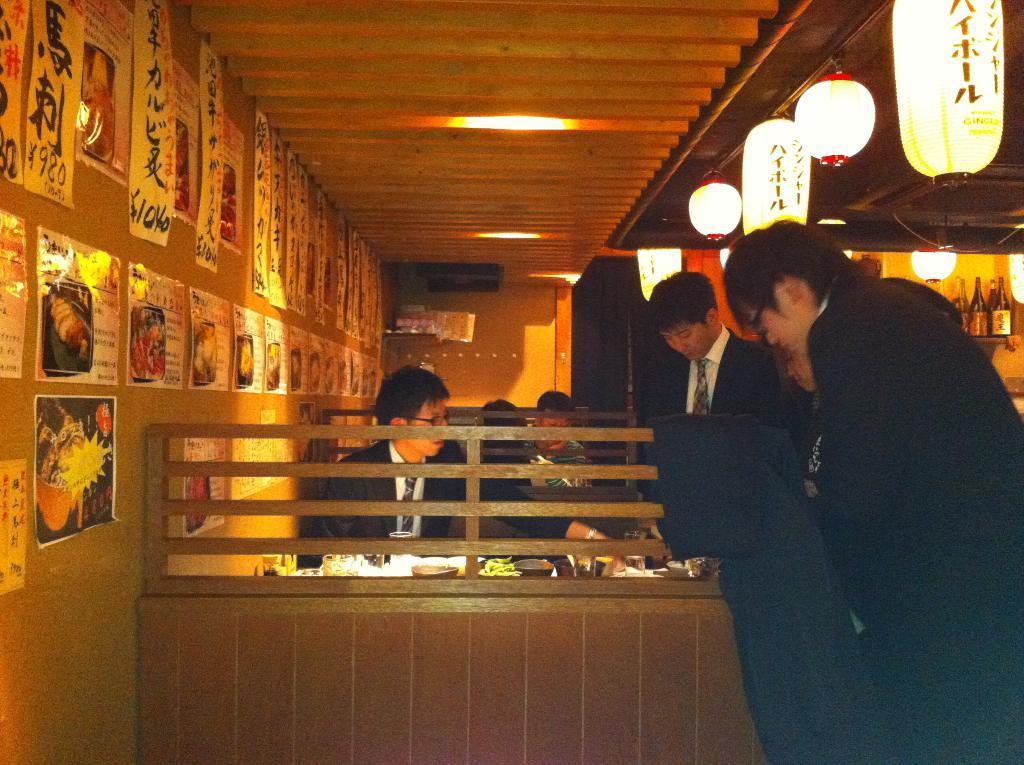In one or two sentences, can you explain what this image depicts? On the right side, we see the people are standing. In front of the picture, we see a man is sitting on the chair. In front of him, we see a table on which the glasses, bowls and some other objects are placed. Behind him, we see two people are sitting. On the right side, we see a rack in which the glass bottles are placed. In the background, we see a wall. On the left side, we see a brown wall on which the posters are pasted. At the top, we see the lanterns and the ceiling of the room. 